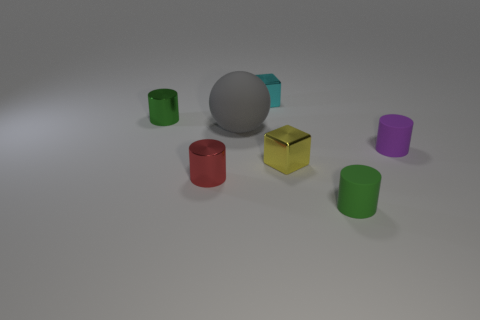There is a small green thing that is right of the tiny green shiny cylinder; what number of green cylinders are behind it?
Offer a very short reply. 1. There is a cylinder that is both to the right of the large gray rubber ball and in front of the tiny purple rubber cylinder; what size is it?
Keep it short and to the point. Small. What number of metal objects are small blocks or balls?
Make the answer very short. 2. What material is the yellow thing?
Make the answer very short. Metal. What material is the cylinder in front of the metallic cylinder that is in front of the green thing left of the tiny green matte cylinder?
Your answer should be very brief. Rubber. What shape is the yellow metallic object that is the same size as the red thing?
Make the answer very short. Cube. How many things are either metal cubes or gray things that are to the right of the small red metal cylinder?
Provide a succinct answer. 3. Does the small green cylinder that is behind the small purple matte object have the same material as the green thing that is on the right side of the big gray rubber thing?
Provide a short and direct response. No. What number of purple objects are either rubber objects or big matte objects?
Offer a very short reply. 1. The gray rubber ball is what size?
Keep it short and to the point. Large. 